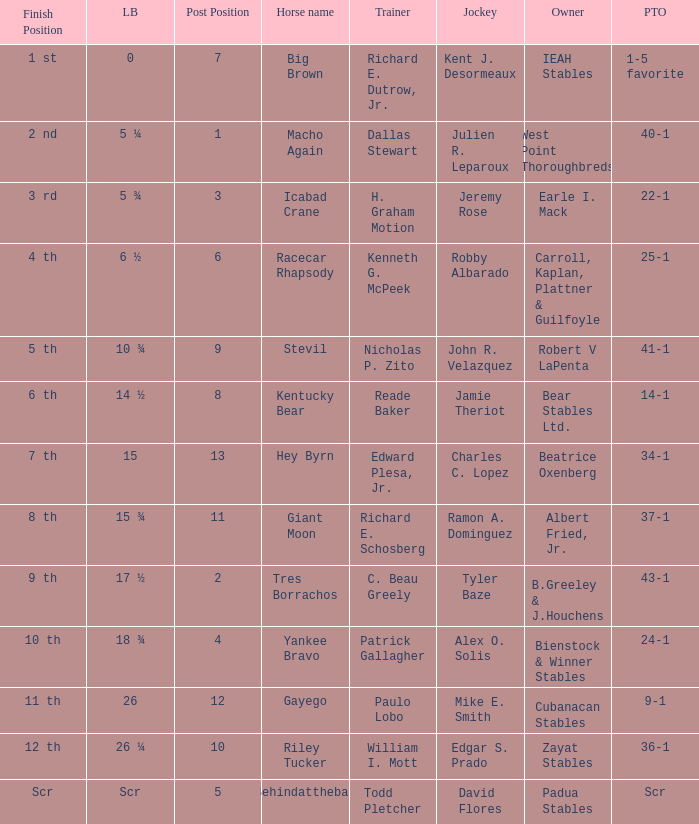Could you help me parse every detail presented in this table? {'header': ['Finish Position', 'LB', 'Post Position', 'Horse name', 'Trainer', 'Jockey', 'Owner', 'PTO'], 'rows': [['1 st', '0', '7', 'Big Brown', 'Richard E. Dutrow, Jr.', 'Kent J. Desormeaux', 'IEAH Stables', '1-5 favorite'], ['2 nd', '5 ¼', '1', 'Macho Again', 'Dallas Stewart', 'Julien R. Leparoux', 'West Point Thoroughbreds', '40-1'], ['3 rd', '5 ¾', '3', 'Icabad Crane', 'H. Graham Motion', 'Jeremy Rose', 'Earle I. Mack', '22-1'], ['4 th', '6 ½', '6', 'Racecar Rhapsody', 'Kenneth G. McPeek', 'Robby Albarado', 'Carroll, Kaplan, Plattner & Guilfoyle', '25-1'], ['5 th', '10 ¾', '9', 'Stevil', 'Nicholas P. Zito', 'John R. Velazquez', 'Robert V LaPenta', '41-1'], ['6 th', '14 ½', '8', 'Kentucky Bear', 'Reade Baker', 'Jamie Theriot', 'Bear Stables Ltd.', '14-1'], ['7 th', '15', '13', 'Hey Byrn', 'Edward Plesa, Jr.', 'Charles C. Lopez', 'Beatrice Oxenberg', '34-1'], ['8 th', '15 ¾', '11', 'Giant Moon', 'Richard E. Schosberg', 'Ramon A. Dominguez', 'Albert Fried, Jr.', '37-1'], ['9 th', '17 ½', '2', 'Tres Borrachos', 'C. Beau Greely', 'Tyler Baze', 'B.Greeley & J.Houchens', '43-1'], ['10 th', '18 ¾', '4', 'Yankee Bravo', 'Patrick Gallagher', 'Alex O. Solis', 'Bienstock & Winner Stables', '24-1'], ['11 th', '26', '12', 'Gayego', 'Paulo Lobo', 'Mike E. Smith', 'Cubanacan Stables', '9-1'], ['12 th', '26 ¼', '10', 'Riley Tucker', 'William I. Mott', 'Edgar S. Prado', 'Zayat Stables', '36-1'], ['Scr', 'Scr', '5', 'Behindatthebar', 'Todd Pletcher', 'David Flores', 'Padua Stables', 'Scr']]} What's the measurement behind jockey ramon a. dominguez? 15 ¾. 